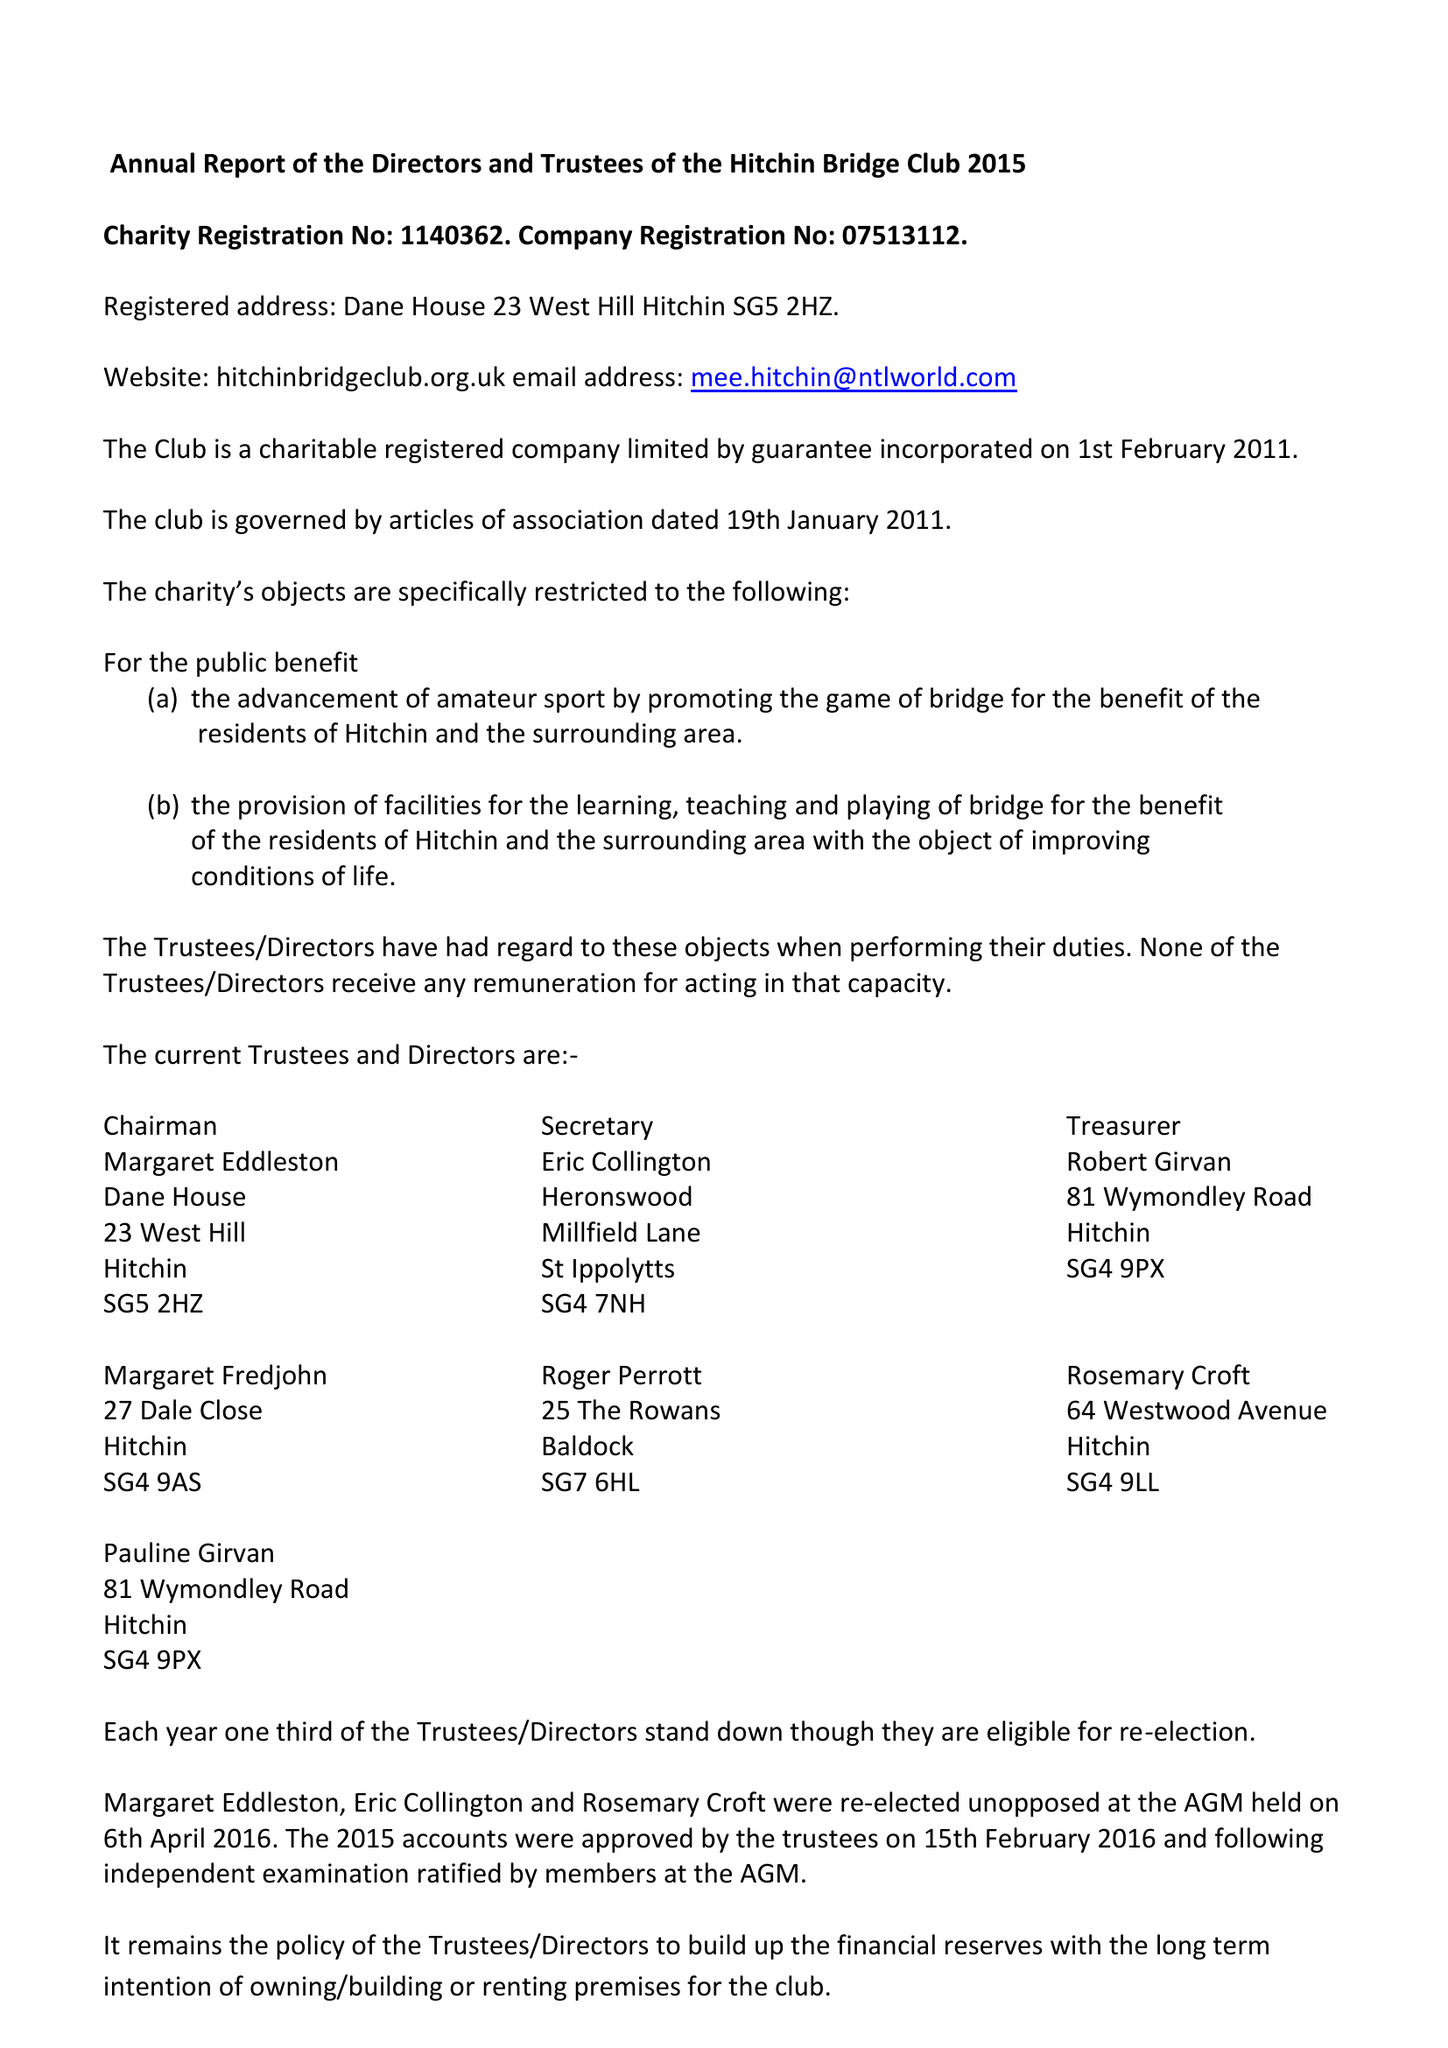What is the value for the income_annually_in_british_pounds?
Answer the question using a single word or phrase. 28931.00 